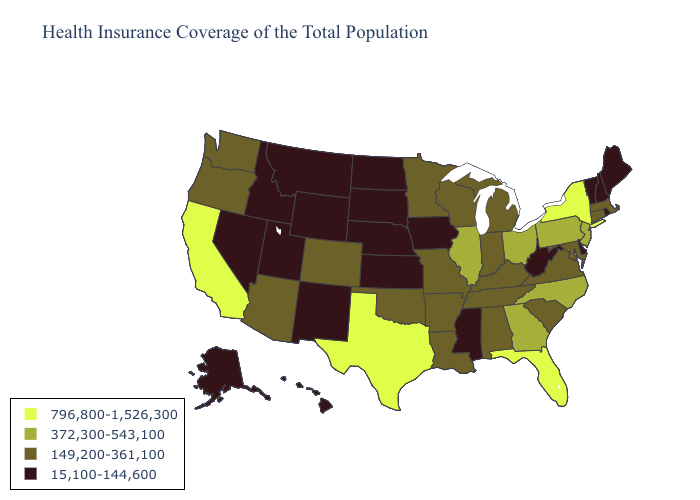Among the states that border Connecticut , which have the highest value?
Give a very brief answer. New York. Among the states that border Missouri , which have the lowest value?
Give a very brief answer. Iowa, Kansas, Nebraska. Name the states that have a value in the range 372,300-543,100?
Concise answer only. Georgia, Illinois, New Jersey, North Carolina, Ohio, Pennsylvania. What is the value of Iowa?
Answer briefly. 15,100-144,600. What is the highest value in the USA?
Keep it brief. 796,800-1,526,300. Name the states that have a value in the range 149,200-361,100?
Keep it brief. Alabama, Arizona, Arkansas, Colorado, Connecticut, Indiana, Kentucky, Louisiana, Maryland, Massachusetts, Michigan, Minnesota, Missouri, Oklahoma, Oregon, South Carolina, Tennessee, Virginia, Washington, Wisconsin. Does Iowa have a lower value than Louisiana?
Give a very brief answer. Yes. What is the lowest value in the MidWest?
Short answer required. 15,100-144,600. Among the states that border Mississippi , which have the lowest value?
Short answer required. Alabama, Arkansas, Louisiana, Tennessee. Does the map have missing data?
Give a very brief answer. No. How many symbols are there in the legend?
Give a very brief answer. 4. What is the value of Montana?
Be succinct. 15,100-144,600. Name the states that have a value in the range 372,300-543,100?
Be succinct. Georgia, Illinois, New Jersey, North Carolina, Ohio, Pennsylvania. What is the value of Maine?
Be succinct. 15,100-144,600. 